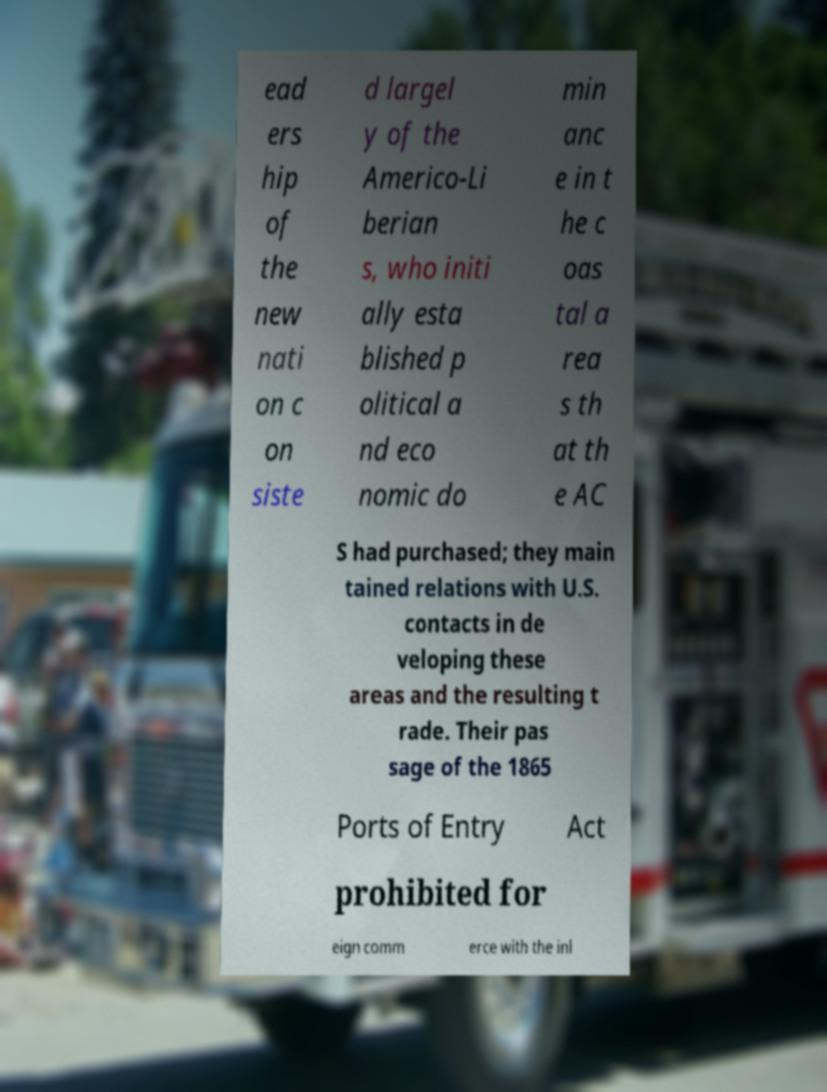Could you assist in decoding the text presented in this image and type it out clearly? ead ers hip of the new nati on c on siste d largel y of the Americo-Li berian s, who initi ally esta blished p olitical a nd eco nomic do min anc e in t he c oas tal a rea s th at th e AC S had purchased; they main tained relations with U.S. contacts in de veloping these areas and the resulting t rade. Their pas sage of the 1865 Ports of Entry Act prohibited for eign comm erce with the inl 